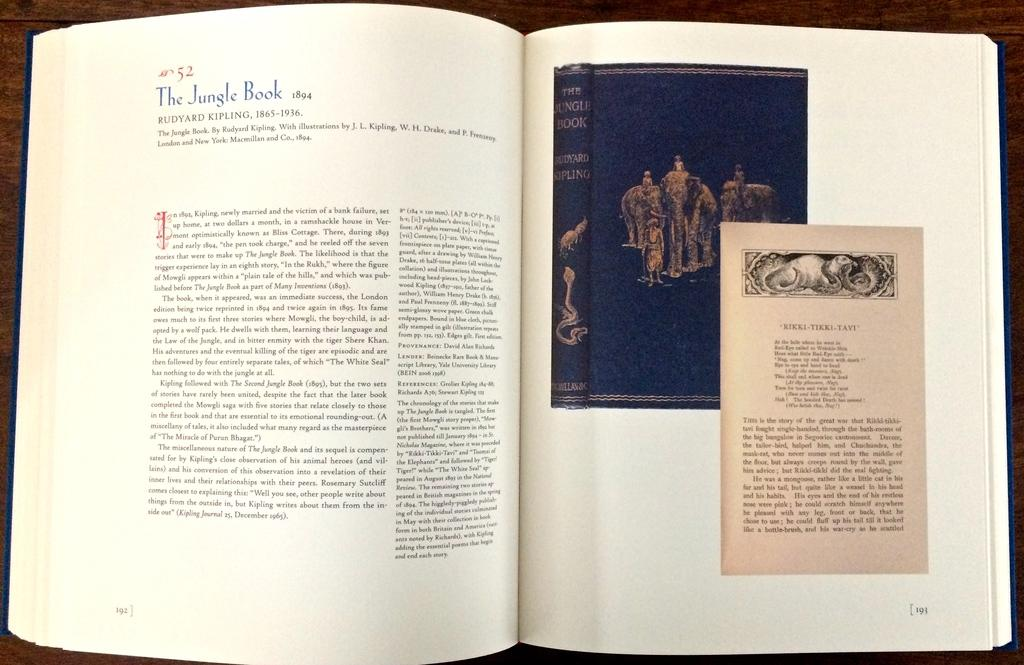<image>
Give a short and clear explanation of the subsequent image. A book about The Jungle Book by Ruyard Kipling is opened to page 192 